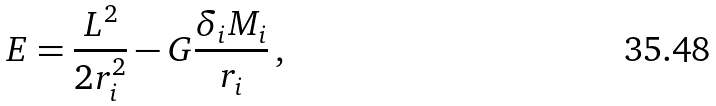Convert formula to latex. <formula><loc_0><loc_0><loc_500><loc_500>E = \frac { L ^ { 2 } } { 2 r _ { i } ^ { 2 } } - G \frac { \delta _ { i } M _ { i } } { r _ { i } } \, ,</formula> 